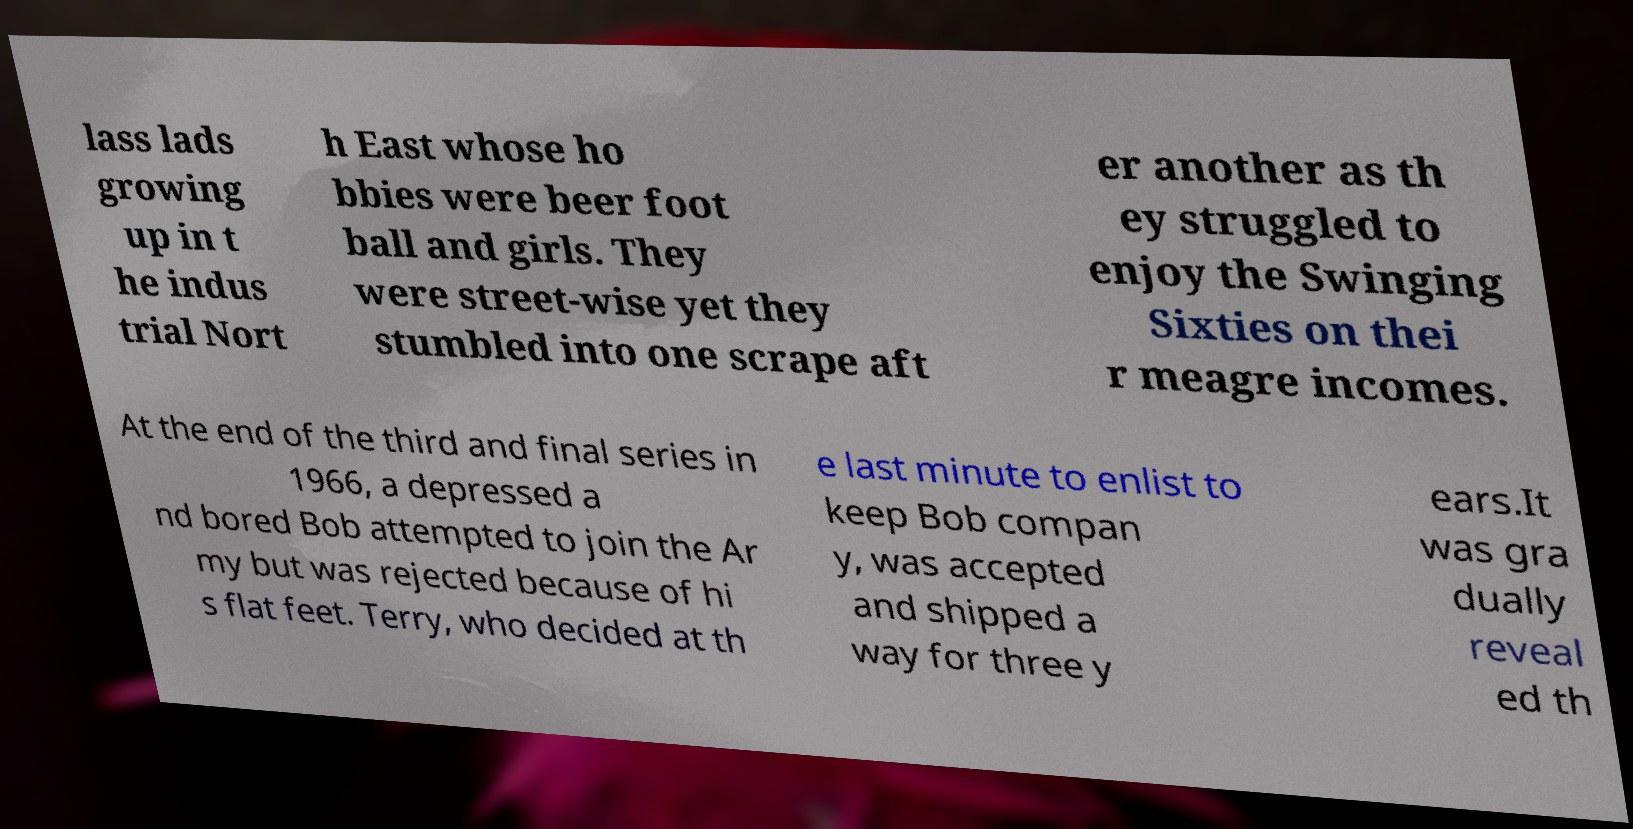Can you accurately transcribe the text from the provided image for me? lass lads growing up in t he indus trial Nort h East whose ho bbies were beer foot ball and girls. They were street-wise yet they stumbled into one scrape aft er another as th ey struggled to enjoy the Swinging Sixties on thei r meagre incomes. At the end of the third and final series in 1966, a depressed a nd bored Bob attempted to join the Ar my but was rejected because of hi s flat feet. Terry, who decided at th e last minute to enlist to keep Bob compan y, was accepted and shipped a way for three y ears.It was gra dually reveal ed th 